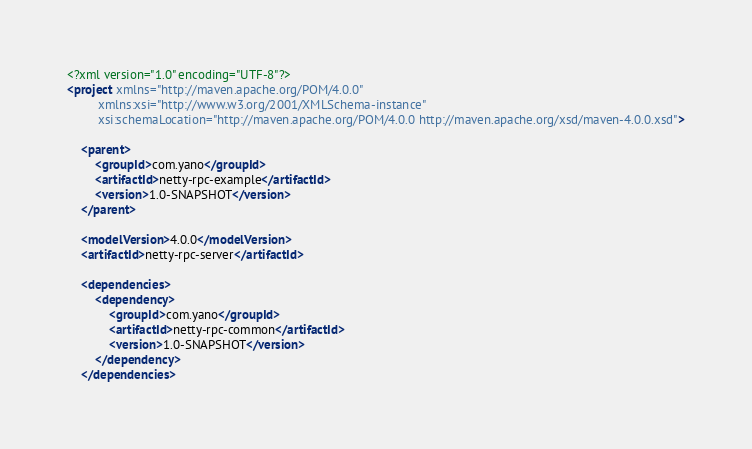Convert code to text. <code><loc_0><loc_0><loc_500><loc_500><_XML_><?xml version="1.0" encoding="UTF-8"?>
<project xmlns="http://maven.apache.org/POM/4.0.0"
         xmlns:xsi="http://www.w3.org/2001/XMLSchema-instance"
         xsi:schemaLocation="http://maven.apache.org/POM/4.0.0 http://maven.apache.org/xsd/maven-4.0.0.xsd">

    <parent>
        <groupId>com.yano</groupId>
        <artifactId>netty-rpc-example</artifactId>
        <version>1.0-SNAPSHOT</version>
    </parent>

    <modelVersion>4.0.0</modelVersion>
    <artifactId>netty-rpc-server</artifactId>

    <dependencies>
        <dependency>
            <groupId>com.yano</groupId>
            <artifactId>netty-rpc-common</artifactId>
            <version>1.0-SNAPSHOT</version>
        </dependency>
    </dependencies>
</code> 